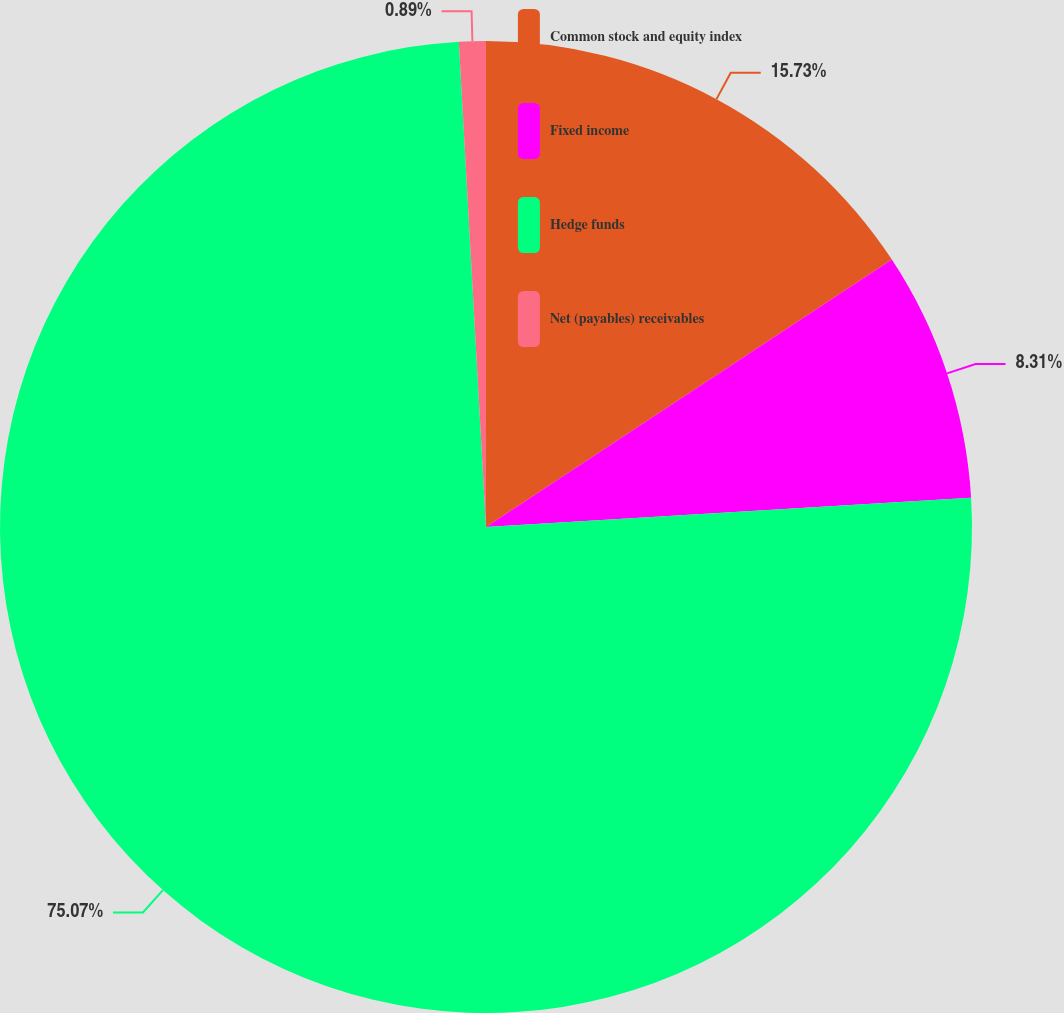Convert chart to OTSL. <chart><loc_0><loc_0><loc_500><loc_500><pie_chart><fcel>Common stock and equity index<fcel>Fixed income<fcel>Hedge funds<fcel>Net (payables) receivables<nl><fcel>15.73%<fcel>8.31%<fcel>75.08%<fcel>0.89%<nl></chart> 